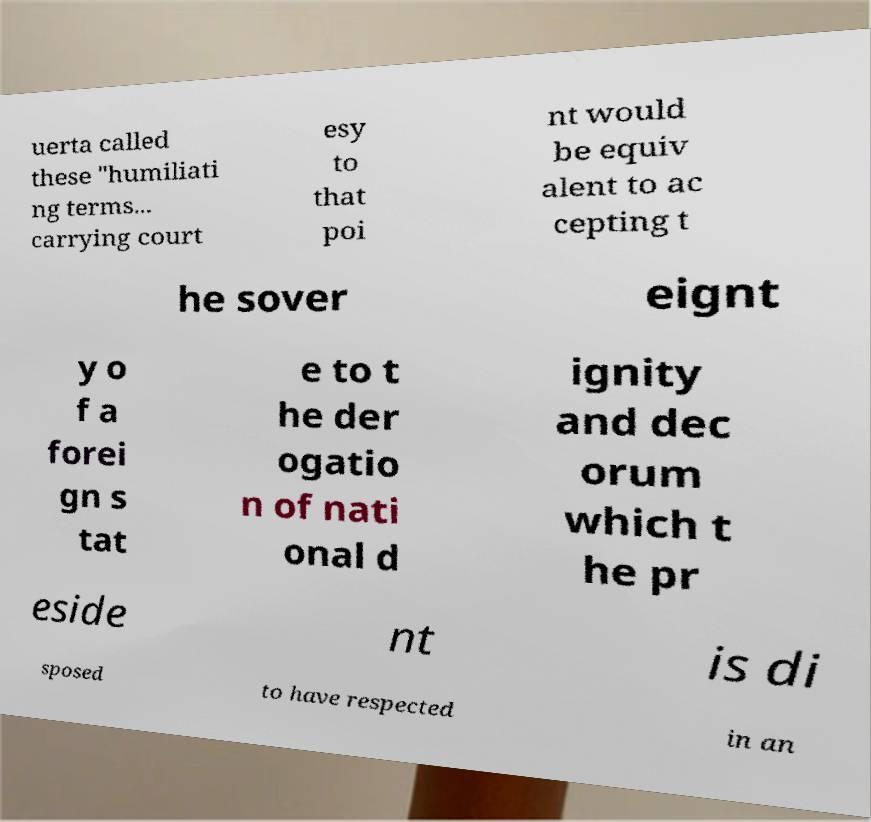There's text embedded in this image that I need extracted. Can you transcribe it verbatim? uerta called these "humiliati ng terms... carrying court esy to that poi nt would be equiv alent to ac cepting t he sover eignt y o f a forei gn s tat e to t he der ogatio n of nati onal d ignity and dec orum which t he pr eside nt is di sposed to have respected in an 